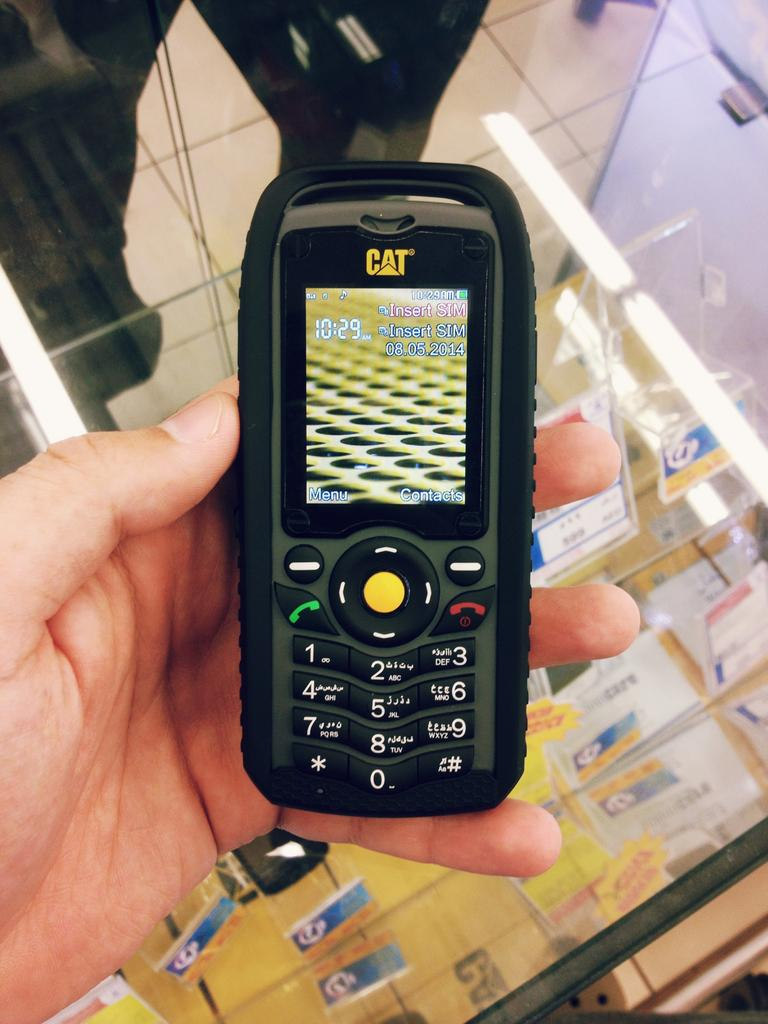<image>
Summarize the visual content of the image. A CAT branded cell phone is held by a hand in a store. 